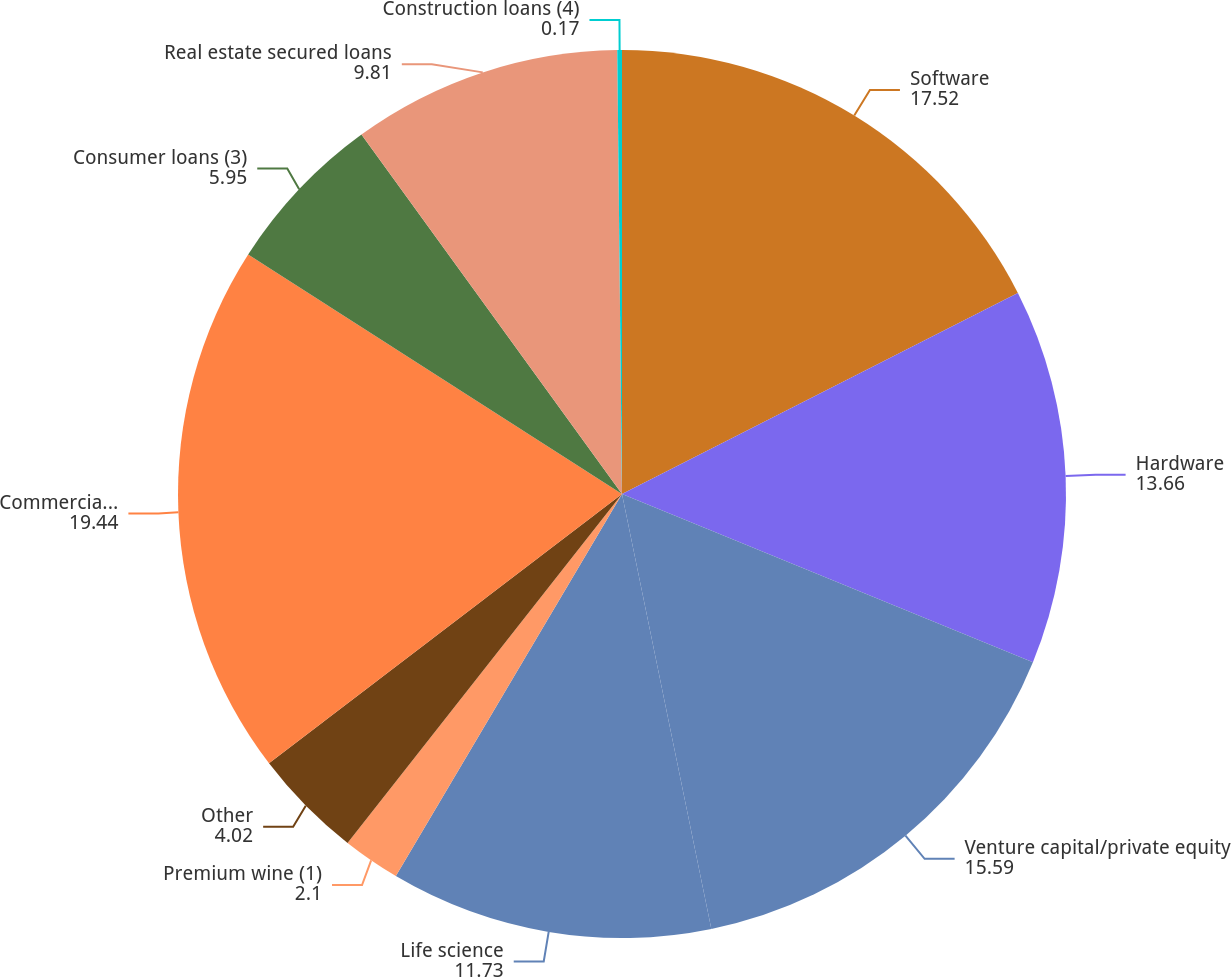<chart> <loc_0><loc_0><loc_500><loc_500><pie_chart><fcel>Software<fcel>Hardware<fcel>Venture capital/private equity<fcel>Life science<fcel>Premium wine (1)<fcel>Other<fcel>Commercial loans (2)<fcel>Consumer loans (3)<fcel>Real estate secured loans<fcel>Construction loans (4)<nl><fcel>17.52%<fcel>13.66%<fcel>15.59%<fcel>11.73%<fcel>2.1%<fcel>4.02%<fcel>19.44%<fcel>5.95%<fcel>9.81%<fcel>0.17%<nl></chart> 